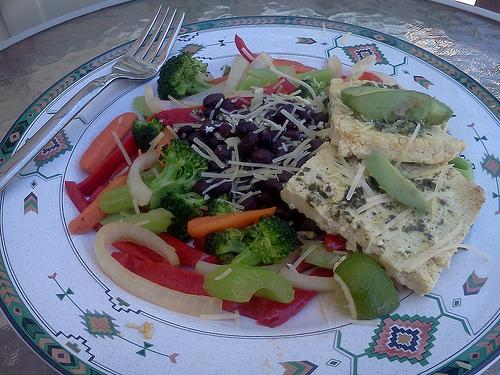Based on the image, count the number of total objects in the salad. There are 29 objects in the salad, including different types of vegetables, garnishes, and toppings. Describe the type of plate shown in the image and provide its position. The plate is a white patterned plate with Native American decoration. Position: (0, 18). Describe the interaction between the fork and the plate in the image. The fork is resting on the plate, partially over the salad, ready to be used for eating the mixed vegetable meal. Analyze the sentiment and emotions conveyed by the image, and explain your reasoning. The image conveys a feeling of freshness, health, and vibrancy due to the colorful mixed vegetable meal and the appetizing presentation on the well-decorated plate. In the image, find anything related to cheese and provide the object's details. The object is tofu with cheese on top. Positions: (293, 121), (346, 80), (297, 121), (416, 130), and (308, 61). How many pieces of broccoli are there in this image and what are their positions? There are 4 pieces of broccoli. Positions: (230, 218), (153, 142), (157, 55), and (150, 52). List all objects you can find in the image related to eating utensils. A metal fork, head of a fork, silver fork sitting on the plate, tines of the silver fork, and a stainless steel fork resting on a plate. What is the garnish on this mixed vegetable meal and where is it located? The garnish is a cut piece of lime. Position: (330, 250). Identify the main dish and its main ingredients in the image. The main dish is a colorful mixed vegetable salad with broccoli, carrot, onion, red pepper, beans, tofu, cheese, and a lime wedge garnish. Considering the diversity of ingredients and presentation, assess the image's quality. The image is of high quality, as it showcases a wide variety of ingredients with different colors, shapes, and textures on an aesthetically pleasing decorated plate. Can you spot any avocado in the salad? Yes What components are making up the colorful mixed vegetable meal? Salad, onions, peppers, carrots, broccoli, tofu with cheese, lime, and beans Isn't it true that you can see a glass of water beside the native American decorated white plate? There's no mention of a glass of water in any of the objects described in the image. What type of utensil is resting on the plate? A stainless steel fork. Which food item has a garnish on top of it? Tofu with cheese What type of peppers are visible in the salad? Red pepper What is the color of the carrot used in this meal? Orange Please count the number of sliced tomatoes that top the salad, aren't they odd? Although there are many objects describing various toppings in the image, there's no mention of sliced tomatoes. What kind of vegetable is cut into a wedge and garnishing the meal? Lime Which object is directly to the right of the wedge of lime garnish? A piece of broccoli Identify one item included in the salad that is not a vegetable. Tofu with cheese on top Where is the bowl of soup placed next to the plate filled with colorful food? There's no mention of a bowl of soup in any of the objects described in the image. Describe the style and design of the plate in the image. It is a white plate with a multi-colored Native American pattern. How many slices of onion are in the mixed vegetable meal? 1 How many pieces of broccoli are visible in the image? 3 What type of food is topped with shredded food in this image? Salad Could you point out the slices of cucumber that are scattered around the vegetables on the plate? There's no mention of cucumber slices in any of the objects described in the image. Does the image contain a metal or a plastic fork? A metal fork Choose the correct description of the meal on the plate: a) a salad b) pasta c) seafood a salad Which object is placed at the top-left corner of the image? A fork. What color is the pattern on the white plate? Multi-colored Name two different types of vegetables in the mixed vegetable meal. Carrot and red pepper Besides tofu, name one other protein source present in the salad. Black beans Can you find the piece of grilled chicken in the middle of the colorful mixed vegetable meal? There's no mention of grilled chicken in any of the objects described in the image. How many croutons are there in the salad with cheese and tofu toppings? There's no mention of croutons in any of the objects described in the image. 